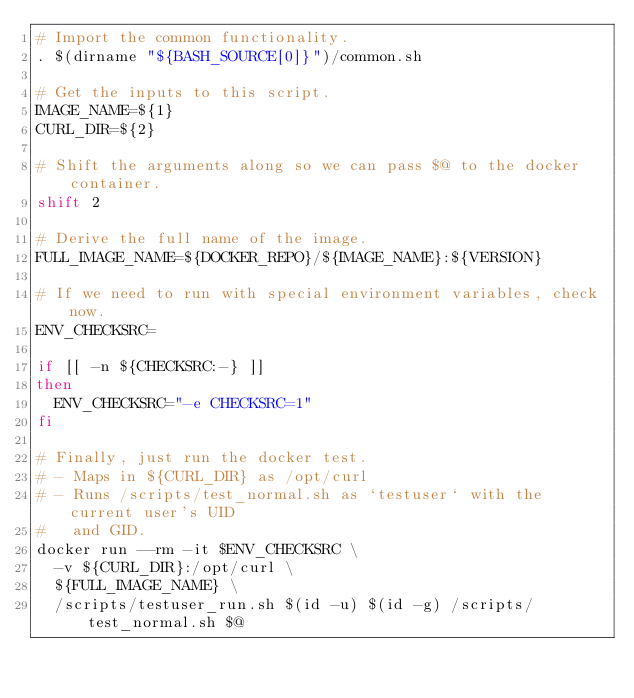Convert code to text. <code><loc_0><loc_0><loc_500><loc_500><_Bash_># Import the common functionality.
. $(dirname "${BASH_SOURCE[0]}")/common.sh

# Get the inputs to this script.
IMAGE_NAME=${1}
CURL_DIR=${2}

# Shift the arguments along so we can pass $@ to the docker container.
shift 2

# Derive the full name of the image.
FULL_IMAGE_NAME=${DOCKER_REPO}/${IMAGE_NAME}:${VERSION}

# If we need to run with special environment variables, check now.
ENV_CHECKSRC=

if [[ -n ${CHECKSRC:-} ]]
then
  ENV_CHECKSRC="-e CHECKSRC=1"
fi

# Finally, just run the docker test.
# - Maps in ${CURL_DIR} as /opt/curl
# - Runs /scripts/test_normal.sh as `testuser` with the current user's UID
#   and GID.
docker run --rm -it $ENV_CHECKSRC \
  -v ${CURL_DIR}:/opt/curl \
  ${FULL_IMAGE_NAME} \
  /scripts/testuser_run.sh $(id -u) $(id -g) /scripts/test_normal.sh $@
</code> 